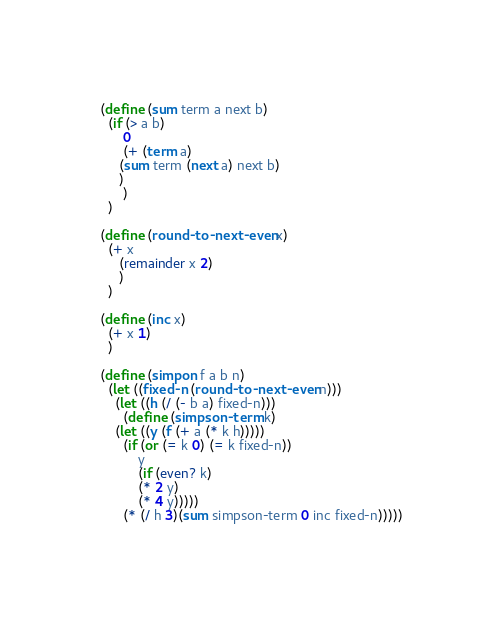Convert code to text. <code><loc_0><loc_0><loc_500><loc_500><_Scheme_>(define (sum term a next b)
  (if (> a b)
      0
      (+ (term a)
	 (sum term (next a) next b)
	 )
      )
  )

(define (round-to-next-even x)
  (+ x
     (remainder x 2)
     )
  )

(define (inc x)
  (+ x 1)
  )

(define (simpon f a b n)
  (let ((fixed-n (round-to-next-even n)))
    (let ((h (/ (- b a) fixed-n)))
      (define (simpson-term k)
	(let ((y (f (+ a (* k h)))))
	  (if (or (= k 0) (= k fixed-n))
	      y
	      (if (even? k)
		  (* 2 y)
		  (* 4 y)))))
      (* (/ h 3)(sum simpson-term 0 inc fixed-n)))))

</code> 